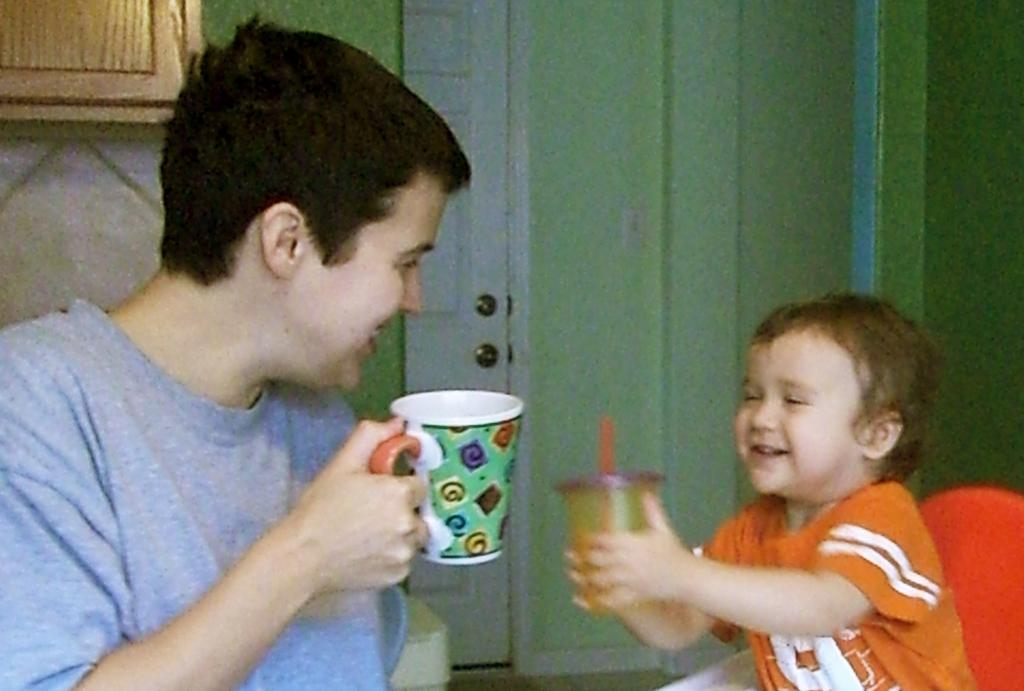Who is present in the image? There is a man and a boy in the image. What is the boy holding in the image? The boy is holding a cup in the image. Where is the jail located in the image? There is no jail present in the image. What type of ghost can be seen interacting with the boy in the image? There is no ghost present in the image; only the man and the boy are visible. 